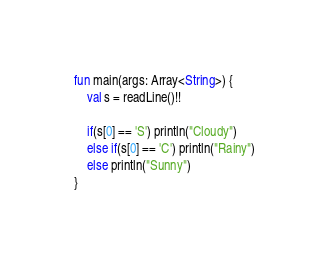Convert code to text. <code><loc_0><loc_0><loc_500><loc_500><_Kotlin_>fun main(args: Array<String>) {
    val s = readLine()!!

    if(s[0] == 'S') println("Cloudy")
    else if(s[0] == 'C') println("Rainy")
    else println("Sunny")
}
</code> 